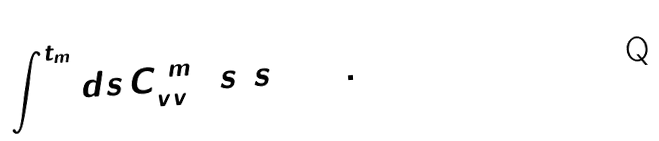<formula> <loc_0><loc_0><loc_500><loc_500>\int _ { 0 } ^ { t _ { m } } d s \, C ^ { ( m ) } _ { v v } ( s ) s = 0 .</formula> 